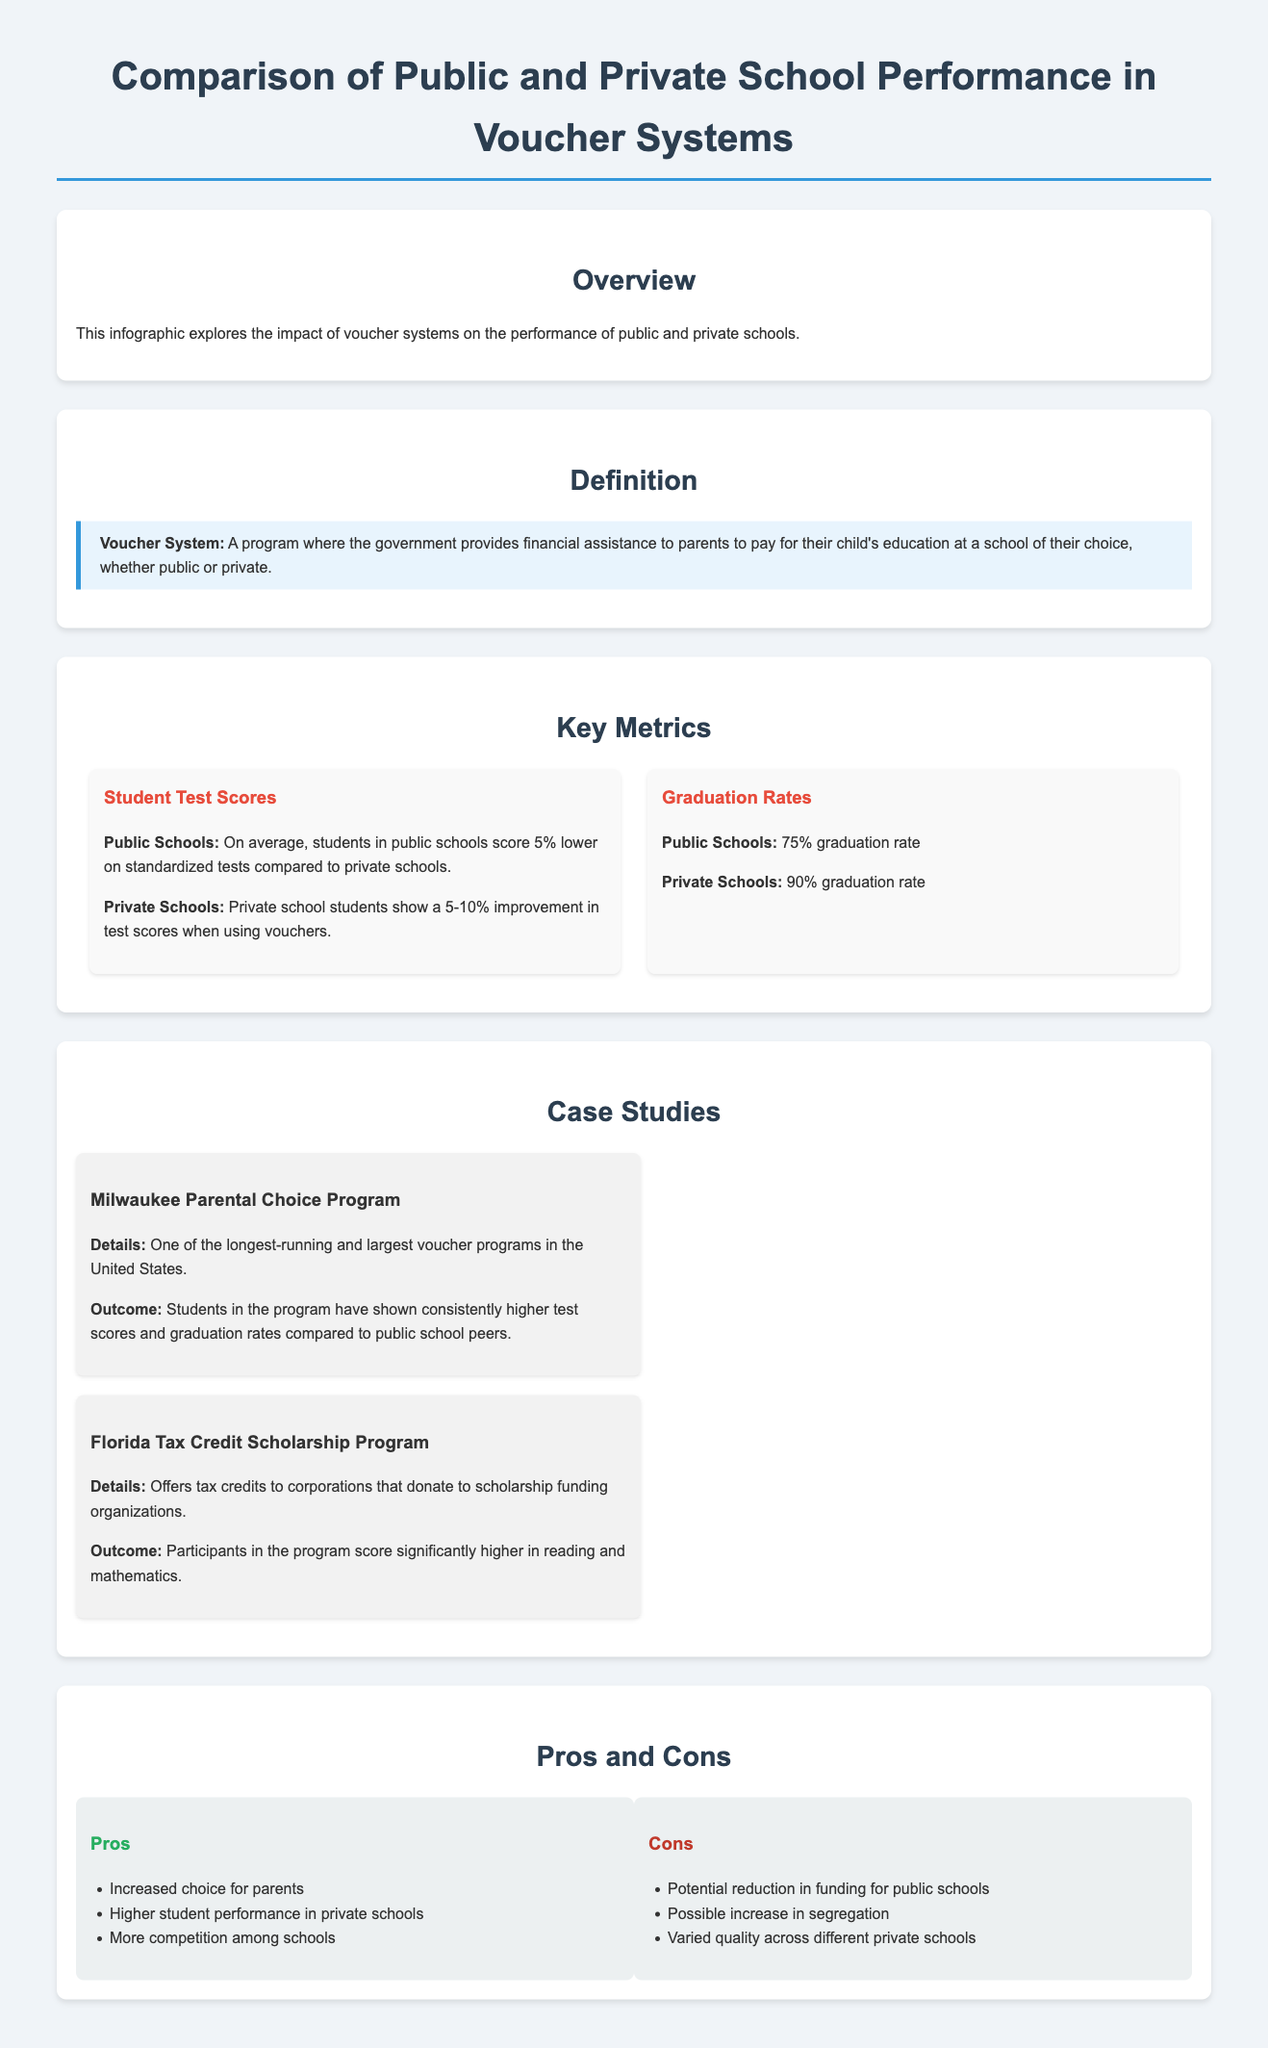What is the average graduation rate for public schools? The document states that public schools have a 75% graduation rate.
Answer: 75% What is the percentage improvement in test scores for private school students using vouchers? The document mentions that private school students show a 5-10% improvement in test scores when using vouchers.
Answer: 5-10% What program is mentioned as one of the longest-running voucher programs? The Milwaukee Parental Choice Program is highlighted in the document as one of the longest-running and largest voucher programs in the US.
Answer: Milwaukee Parental Choice Program What is a major pro of voucher systems according to the infographic? The document lists increased choice for parents as a pro of voucher systems.
Answer: Increased choice for parents What is one potential con of voucher systems as mentioned in the infographic? The document mentions that a potential reduction in funding for public schools is a con of voucher systems.
Answer: Reduction in funding for public schools What is the graduation rate for private schools? The document states that private schools have a 90% graduation rate.
Answer: 90% In which case study do participants score significantly higher in reading and mathematics? The Florida Tax Credit Scholarship Program is noted in the document for participants scoring significantly higher in reading and mathematics.
Answer: Florida Tax Credit Scholarship Program What color is used for the headings in the infographic? The headings are colored in a shade indicated as #2c3e50 in the document.
Answer: #2c3e50 